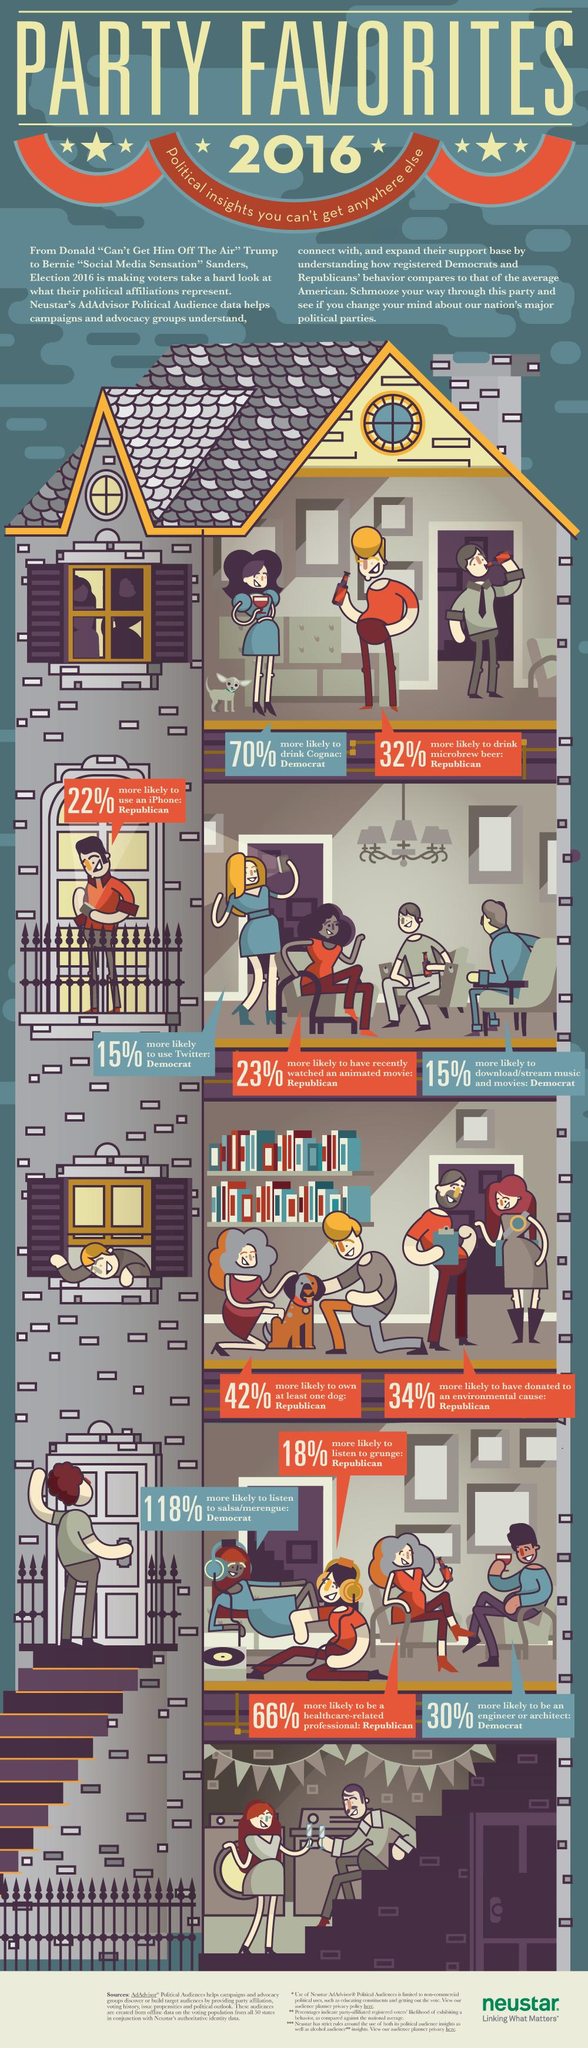Mention a couple of crucial points in this snapshot. Democrats have a strong interest in being able to download and stream movies and music. According to a recent survey, 85% of Democrats who are interested in Twitter have shown an interest in the platform. 